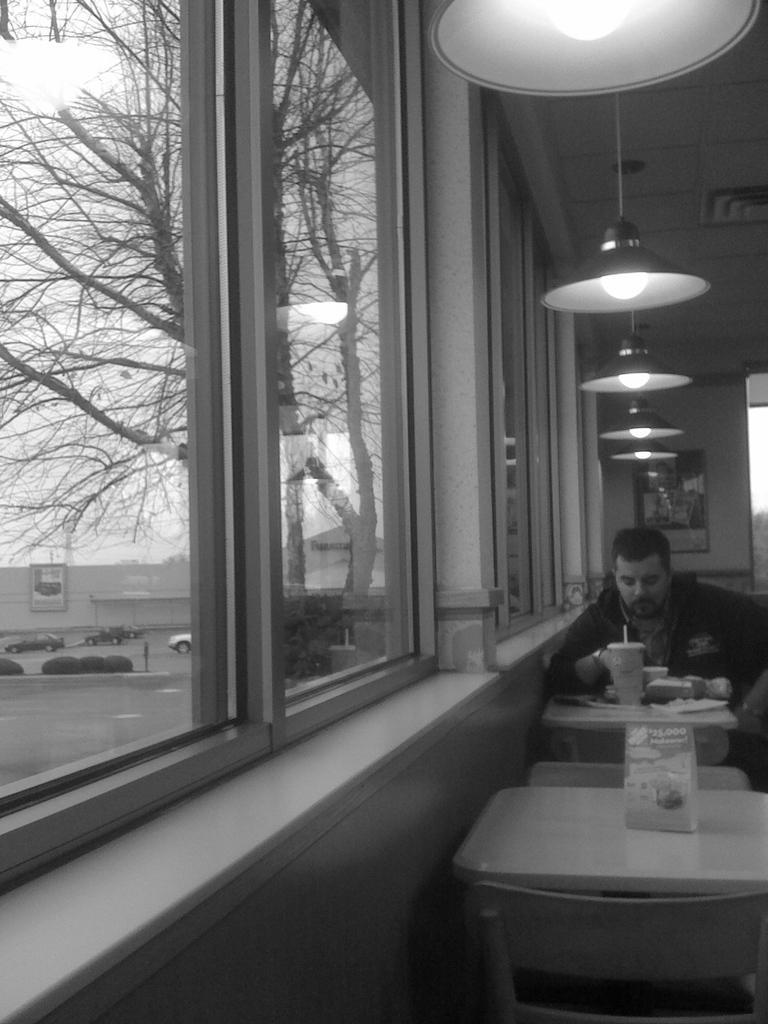Please provide a concise description of this image. In this image i can see a person sitting on the table and having some food at the left side of the image there are windows,cars,trees and at the top of the image there are lights. 